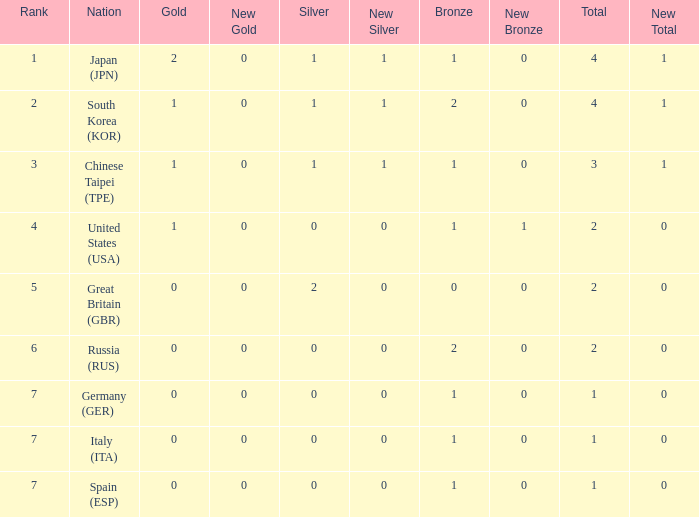What is the rank of the country with more than 2 medals, and 2 gold medals? 1.0. 